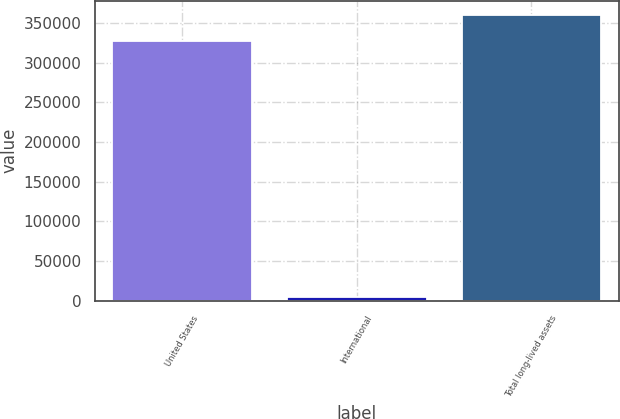<chart> <loc_0><loc_0><loc_500><loc_500><bar_chart><fcel>United States<fcel>International<fcel>Total long-lived assets<nl><fcel>327250<fcel>5412<fcel>359975<nl></chart> 